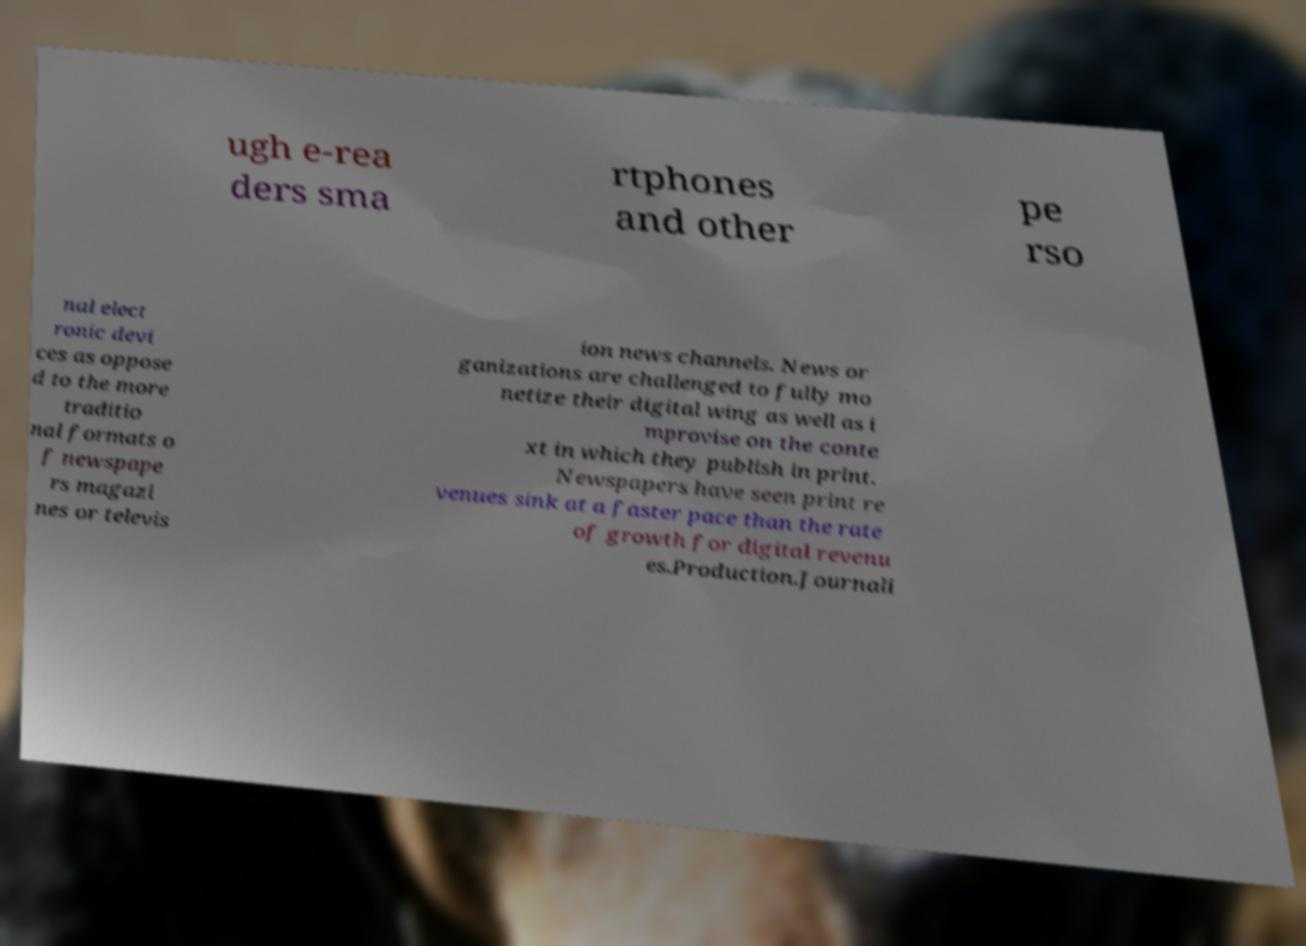Could you extract and type out the text from this image? ugh e-rea ders sma rtphones and other pe rso nal elect ronic devi ces as oppose d to the more traditio nal formats o f newspape rs magazi nes or televis ion news channels. News or ganizations are challenged to fully mo netize their digital wing as well as i mprovise on the conte xt in which they publish in print. Newspapers have seen print re venues sink at a faster pace than the rate of growth for digital revenu es.Production.Journali 